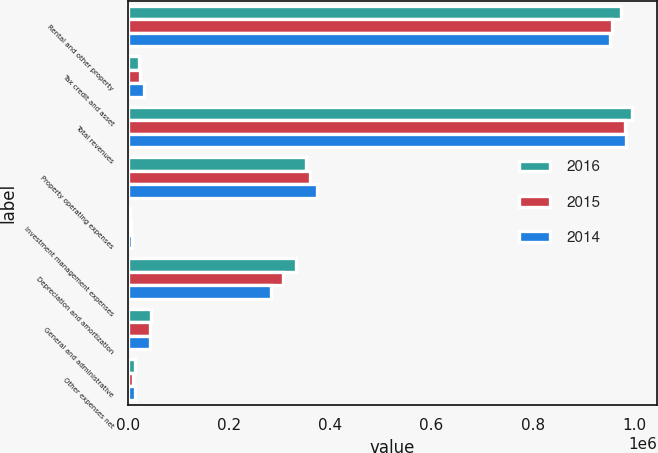Convert chart. <chart><loc_0><loc_0><loc_500><loc_500><stacked_bar_chart><ecel><fcel>Rental and other property<fcel>Tax credit and asset<fcel>Total revenues<fcel>Property operating expenses<fcel>Investment management expenses<fcel>Depreciation and amortization<fcel>General and administrative<fcel>Other expenses net<nl><fcel>2016<fcel>974531<fcel>21323<fcel>995854<fcel>352427<fcel>4333<fcel>333066<fcel>44937<fcel>14295<nl><fcel>2015<fcel>956954<fcel>24356<fcel>981310<fcel>359393<fcel>5855<fcel>306301<fcel>43178<fcel>10368<nl><fcel>2014<fcel>952831<fcel>31532<fcel>984363<fcel>373654<fcel>7310<fcel>282608<fcel>44092<fcel>14349<nl></chart> 